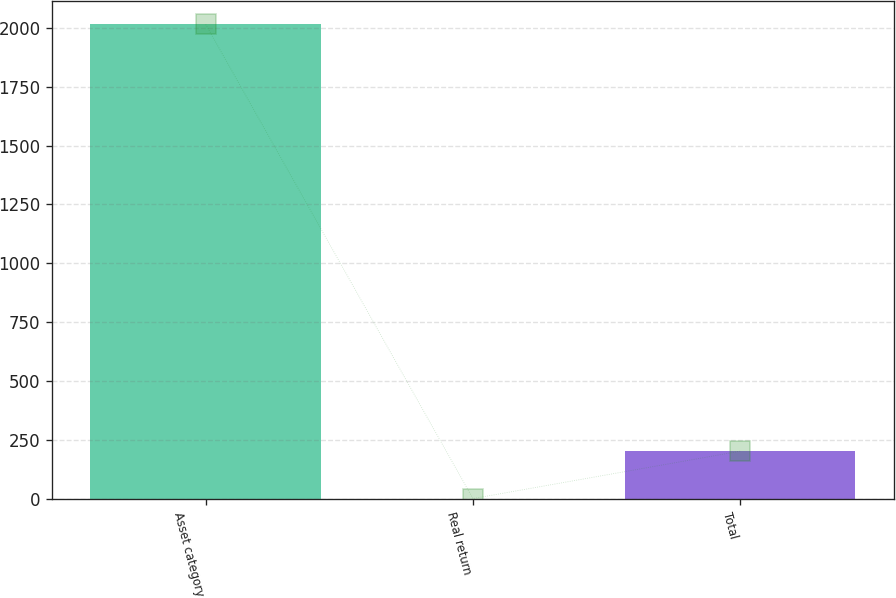Convert chart. <chart><loc_0><loc_0><loc_500><loc_500><bar_chart><fcel>Asset category<fcel>Real return<fcel>Total<nl><fcel>2014<fcel>1.6<fcel>202.84<nl></chart> 